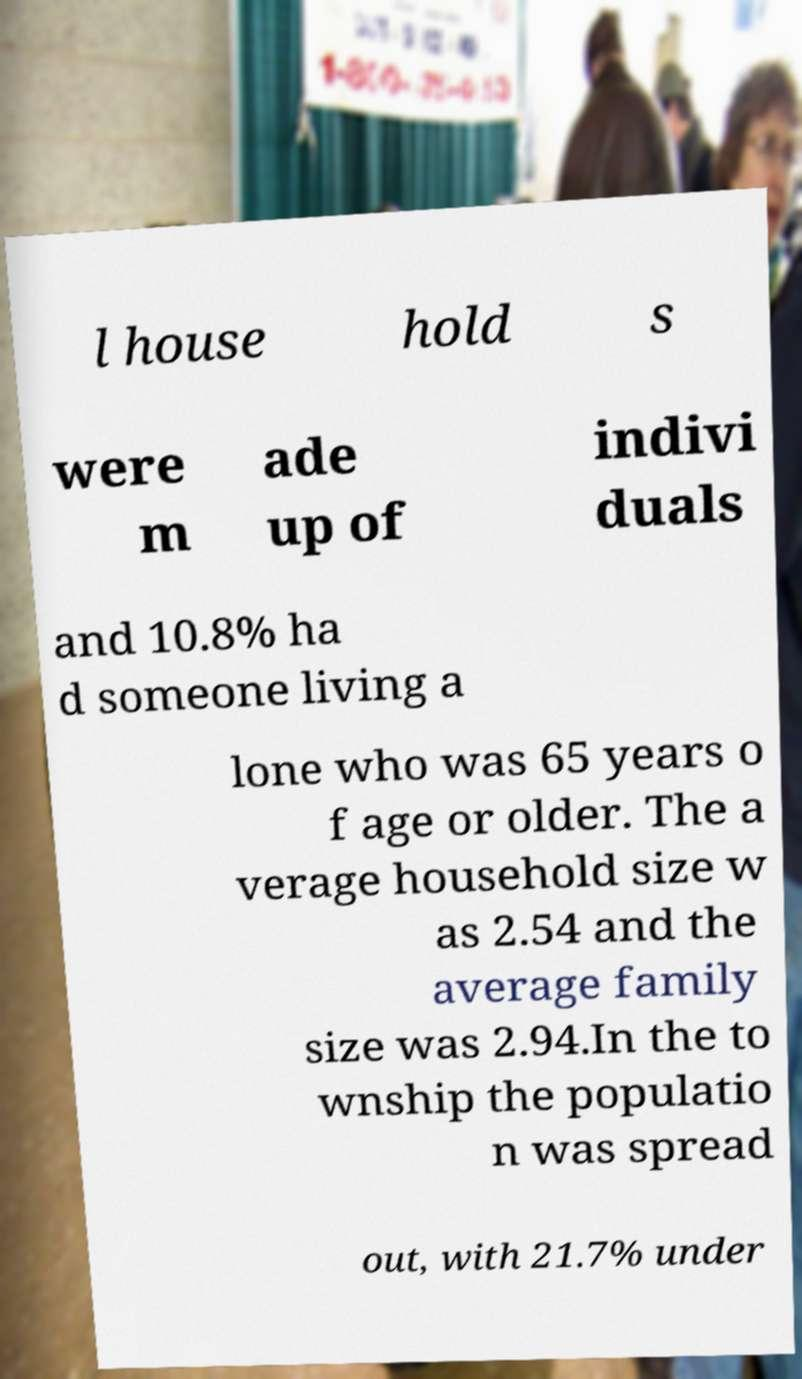Could you extract and type out the text from this image? l house hold s were m ade up of indivi duals and 10.8% ha d someone living a lone who was 65 years o f age or older. The a verage household size w as 2.54 and the average family size was 2.94.In the to wnship the populatio n was spread out, with 21.7% under 